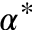<formula> <loc_0><loc_0><loc_500><loc_500>\alpha ^ { * }</formula> 